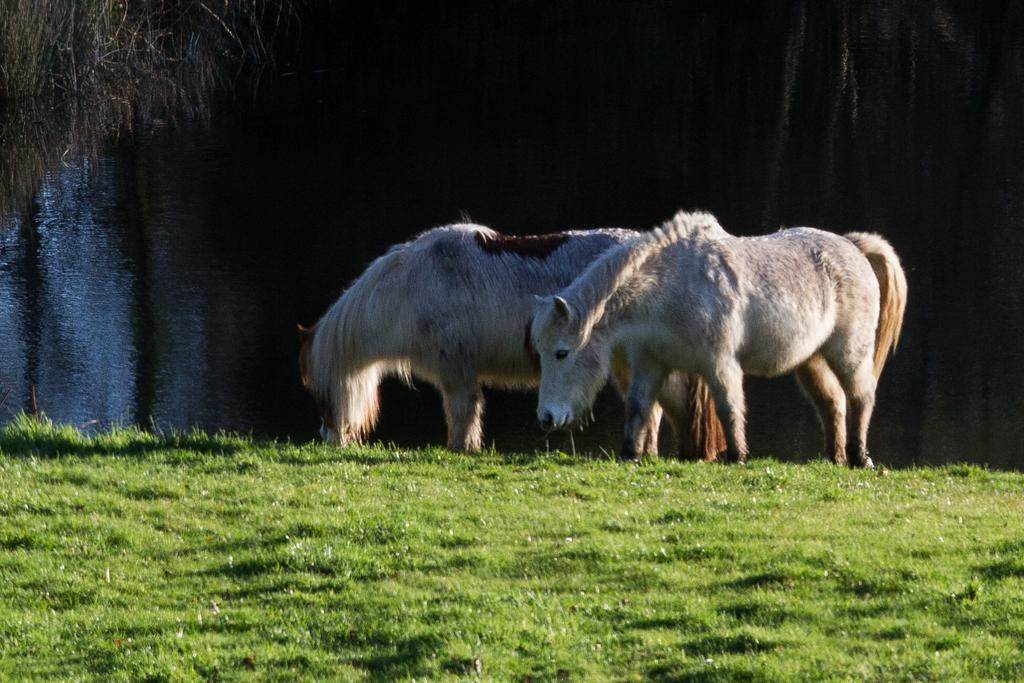What animals can be seen in the image? There are horses in the image. What type of terrain is visible in the image? There is grass on the ground in the image. What other natural elements can be seen in the image? There are trees and water visible in the image. What type of lipstick is the baby wearing in the image? There is no baby or lipstick present in the image; it features horses in a natural setting. 